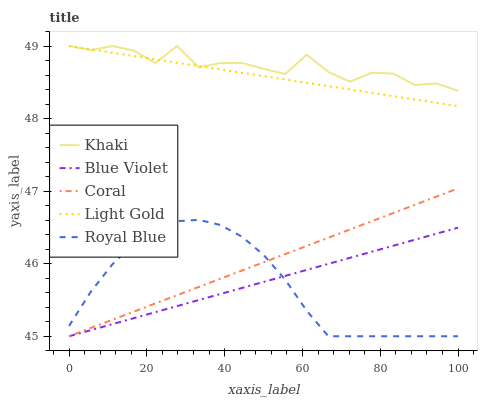Does Coral have the minimum area under the curve?
Answer yes or no. No. Does Coral have the maximum area under the curve?
Answer yes or no. No. Is Coral the smoothest?
Answer yes or no. No. Is Coral the roughest?
Answer yes or no. No. Does Khaki have the lowest value?
Answer yes or no. No. Does Coral have the highest value?
Answer yes or no. No. Is Blue Violet less than Khaki?
Answer yes or no. Yes. Is Khaki greater than Royal Blue?
Answer yes or no. Yes. Does Blue Violet intersect Khaki?
Answer yes or no. No. 